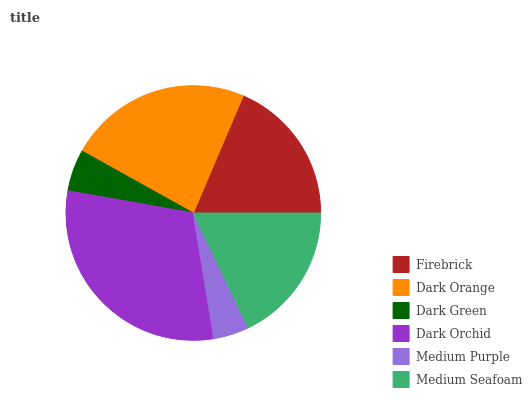Is Medium Purple the minimum?
Answer yes or no. Yes. Is Dark Orchid the maximum?
Answer yes or no. Yes. Is Dark Orange the minimum?
Answer yes or no. No. Is Dark Orange the maximum?
Answer yes or no. No. Is Dark Orange greater than Firebrick?
Answer yes or no. Yes. Is Firebrick less than Dark Orange?
Answer yes or no. Yes. Is Firebrick greater than Dark Orange?
Answer yes or no. No. Is Dark Orange less than Firebrick?
Answer yes or no. No. Is Firebrick the high median?
Answer yes or no. Yes. Is Medium Seafoam the low median?
Answer yes or no. Yes. Is Dark Green the high median?
Answer yes or no. No. Is Dark Green the low median?
Answer yes or no. No. 